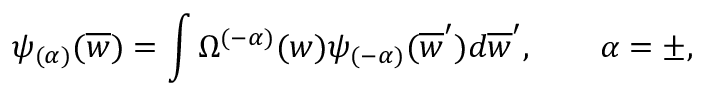Convert formula to latex. <formula><loc_0><loc_0><loc_500><loc_500>\psi _ { ( \alpha ) } ( \overline { w } ) = \int \Omega ^ { ( - \alpha ) } ( w ) \psi _ { ( - \alpha ) } ( \overline { w } ^ { \prime } ) d \overline { w } ^ { \prime } , \quad \alpha = \pm ,</formula> 